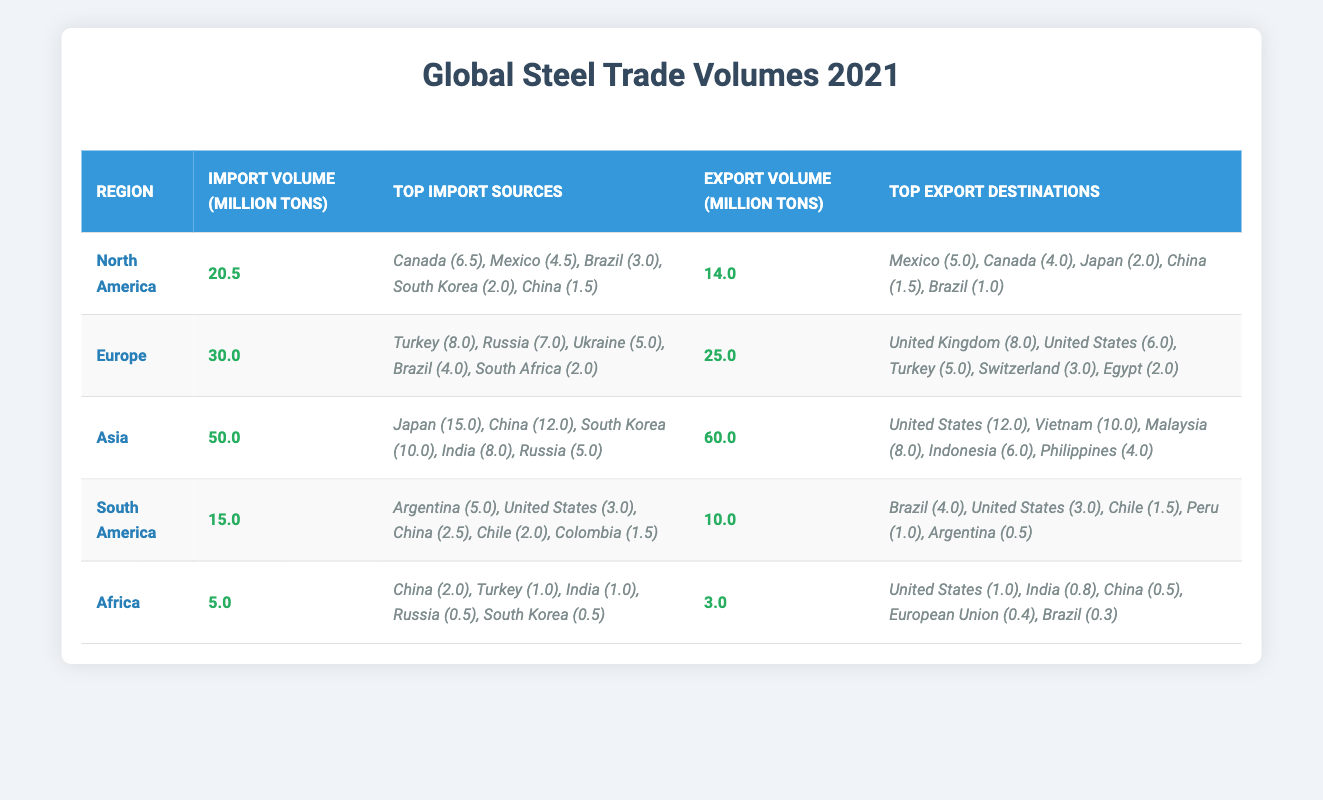What is the total import volume of steel in North America? According to the table, the import volume of steel in North America is provided directly under the imports column. It states that the total import volume is 20.5 million tons.
Answer: 20.5 million tons Which region had the highest export volume of steel in 2021? By comparing the export volumes across all regions listed in the table, Asia has the highest export volume at 60.0 million tons, followed by Europe at 25.0 million tons.
Answer: Asia What are the top two sources of steel imports for South America? Looking at the imports for South America, the top two sources listed are Argentina with 5.0 million tons and the United States with 3.0 million tons.
Answer: Argentina (5.0), United States (3.0) Is the export volume of Africa greater than its import volume? The export volume for Africa is 3.0 million tons and the import volume is 5.0 million tons. Since 3.0 is less than 5.0, this statement is false.
Answer: No What is the total volume of steel imported by Asia and Europe combined? To find the total import volume, we will add Asia's import volume of 50.0 million tons to Europe's import volume of 30.0 million tons. Thus, 50.0 + 30.0 = 80.0 million tons.
Answer: 80.0 million tons Which country is the largest source of steel imports for Asia? The largest source of steel imports for Asia is Japan, with an import volume of 15.0 million tons listed in the imports section.
Answer: Japan (15.0) What is the difference in import volumes between Europe and North America? By finding the import volumes, Europe has 30.0 million tons and North America has 20.5 million tons. The difference is 30.0 - 20.5 = 9.5 million tons, indicating that Europe imports more.
Answer: 9.5 million tons Did South America export more steel to Brazil than to the United States in 2021? For South America, the export volume to Brazil is 4.0 million tons, whereas the export volume to the United States is 3.0 million tons. Since 4.0 is greater than 3.0, this statement is true.
Answer: Yes What percentage of Asia's total exported steel went to the United States? The total export volume from Asia is 60.0 million tons and the export volume to the United States is 12.0 million tons. The percentage can be calculated as (12.0 / 60.0) * 100 = 20%.
Answer: 20% 